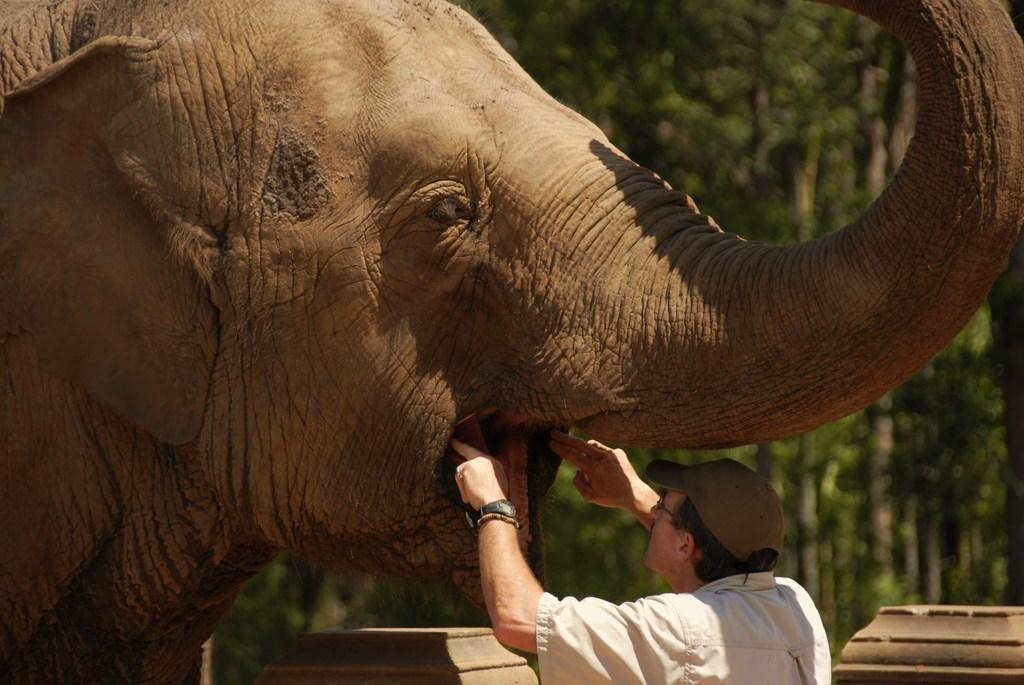What is the main subject on the right side of the image? There is a person on the right side of the image. What is the person doing in the image? The person is checking the mouth of an elephant. Where is the elephant located in the image? The elephant is on the left side of the image. What can be seen in the background of the image? There are trees in the background of the image. How long does it take for the person to offer a minute to the elephant in the image? There is no indication in the image that the person is offering a minute to the elephant, and therefore no such activity can be observed. 